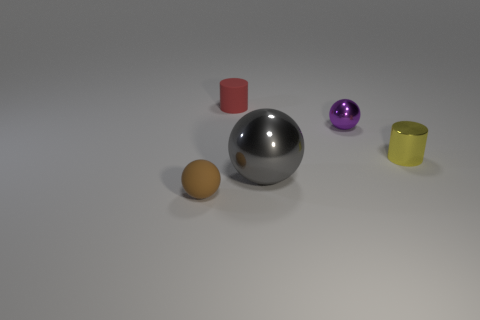Add 3 tiny metallic things. How many objects exist? 8 Subtract all cylinders. How many objects are left? 3 Add 4 brown things. How many brown things are left? 5 Add 1 tiny yellow rubber objects. How many tiny yellow rubber objects exist? 1 Subtract 0 purple cylinders. How many objects are left? 5 Subtract all tiny green cubes. Subtract all brown balls. How many objects are left? 4 